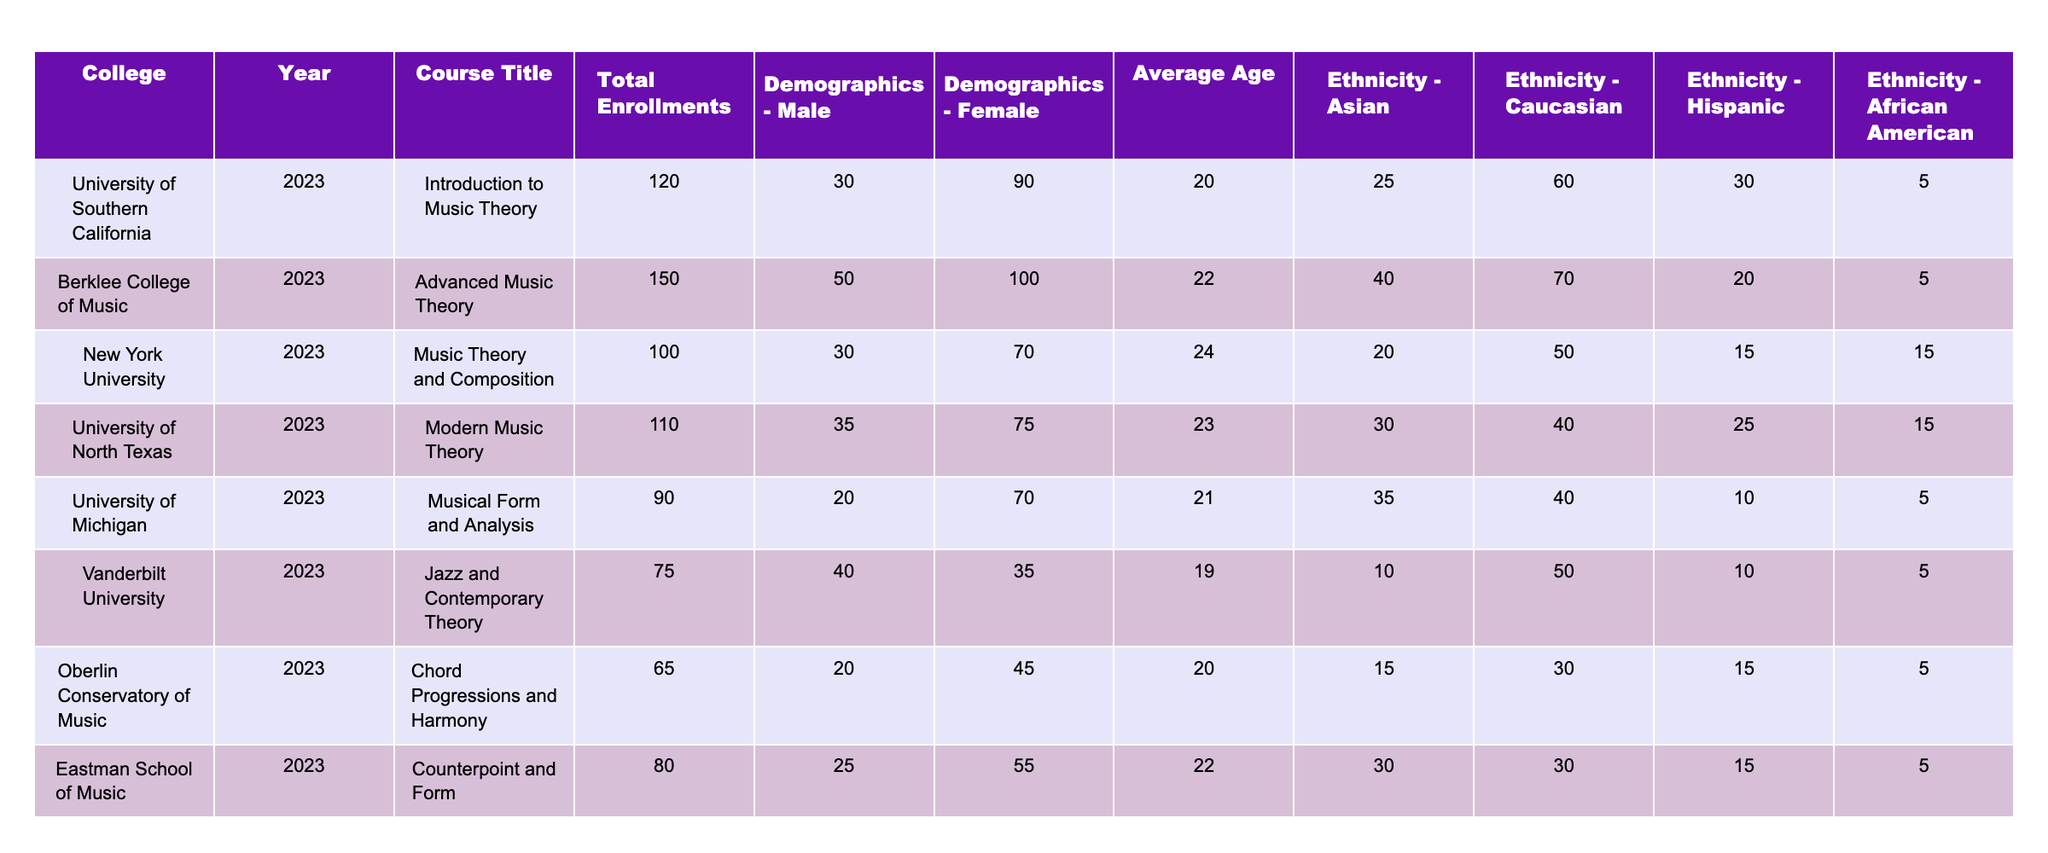What is the total enrollment for the Introduction to Music Theory course at the University of Southern California? The table directly states that the total enrollment for that course is 120.
Answer: 120 Which course had the highest number of female enrollments? By comparing the female enrollment numbers across the courses, Berklee College of Music has 100 female enrollments, which is the highest.
Answer: 100 What is the average age of students enrolled in the Jazz and Contemporary Theory course at Vanderbilt University? The table indicates that the average age of students in that course is 19.
Answer: 19 How many more male students are enrolled in the Advanced Music Theory course compared to the Modern Music Theory course? The Advanced Music Theory course has 50 male students, while the Modern Music Theory course has 35, resulting in a difference of 15 (50 - 35 = 15).
Answer: 15 Is the percentage of Hispanic students higher in the Introduction to Music Theory course than in the Counterpoint and Form course? In the Introduction to Music Theory, 5 out of 120 students are Hispanic (about 4.17%), and in the Counterpoint and Form course, 15 out of 80 students are Hispanic (18.75%). Therefore, the percentage is not higher.
Answer: No What is the total number of students enrolled across all courses listed in the table? Adding the total enrollments together from each course gives 120 + 150 + 100 + 110 + 90 + 75 + 65 + 80 = 990.
Answer: 990 Which college has the most diverse ethnic representation among students in Music Theory courses? Reviewing the diversity, Berklee College of Music has 4 different ethnicities represented with substantial numbers: 40 Asian, 70 Caucasian, 20 Hispanic, and 5 African American, indicating good diversity.
Answer: Berklee College of Music How does the average age of enrolled students compare between the most and least popular courses by enrollment? The most popular course by enrollment is Advanced Music Theory with an average age of 22, and the least popular, Chord Progressions and Harmony, has an average age of 20. The difference in average ages is 2 years (22 - 20 = 2).
Answer: 2 Is the enrollment for Music Theory and Composition equal to or greater than that of Modern Music Theory? The enrollment for Music Theory and Composition is 100, while Modern Music Theory is 110. Therefore, it is not equal to or greater.
Answer: No Which course has the highest enrollment for Asian students, and how many are enrolled? Looking closely at the ethnic representation, the Advanced Music Theory course has the highest number of Asian students with 40 enrolled.
Answer: 40 